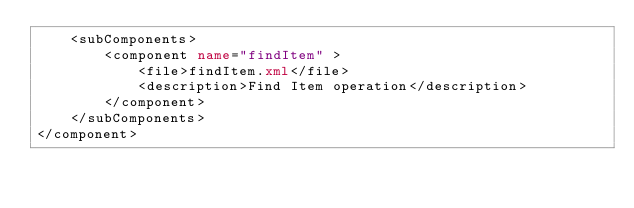Convert code to text. <code><loc_0><loc_0><loc_500><loc_500><_XML_>    <subComponents>
        <component name="findItem" >
            <file>findItem.xml</file>
            <description>Find Item operation</description>
        </component>
    </subComponents>
</component></code> 